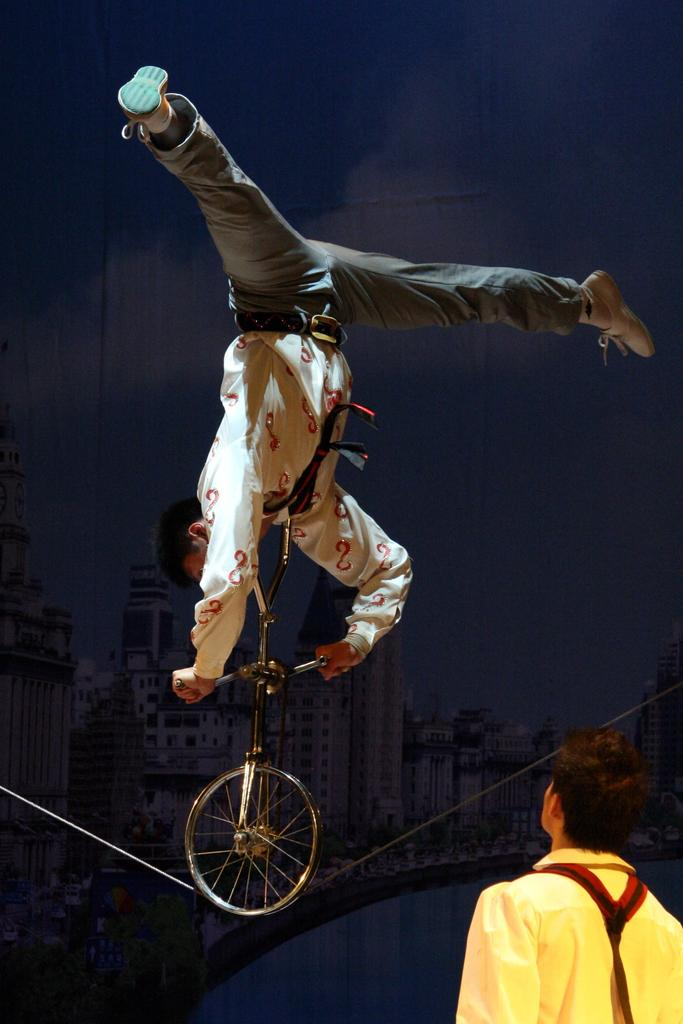What is the main object in the image? There is a bicycle in the image. How many people are present in the image? There are two people in the image. What can be seen in the background of the image? There is a building in the background of the image. Can you describe the lighting in the image? The image is slightly dark. What type of trees can be seen growing around the bicycle in the image? There are no trees visible in the image; it only features a bicycle, two people, and a building in the background. 